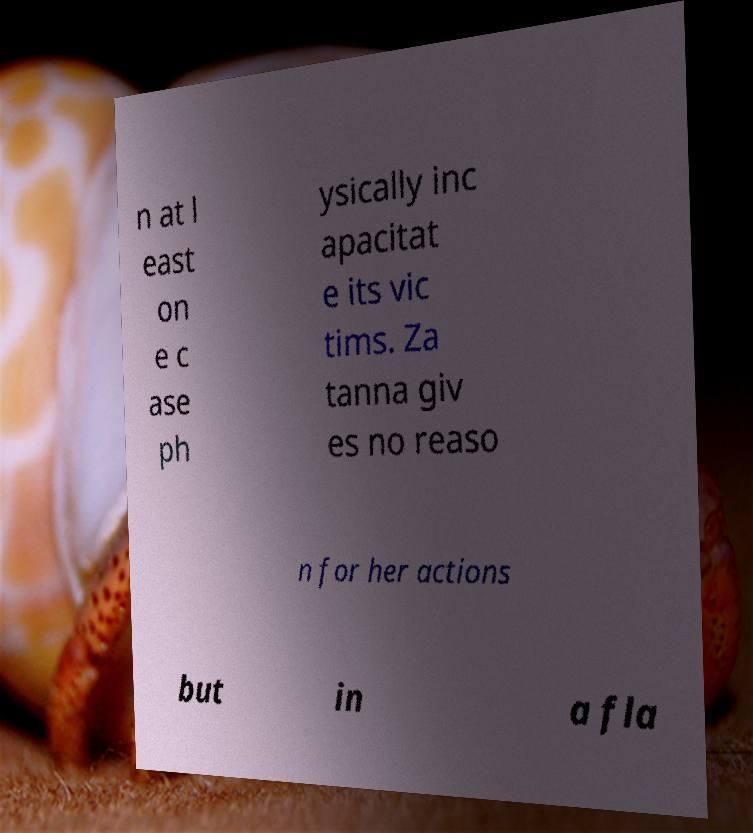Could you extract and type out the text from this image? n at l east on e c ase ph ysically inc apacitat e its vic tims. Za tanna giv es no reaso n for her actions but in a fla 